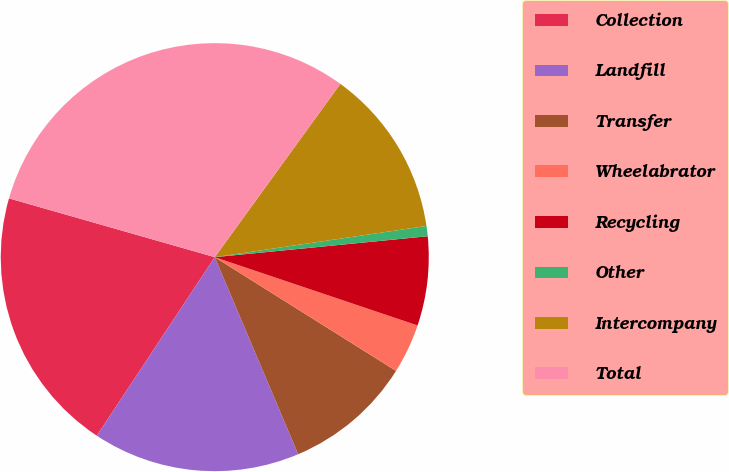<chart> <loc_0><loc_0><loc_500><loc_500><pie_chart><fcel>Collection<fcel>Landfill<fcel>Transfer<fcel>Wheelabrator<fcel>Recycling<fcel>Other<fcel>Intercompany<fcel>Total<nl><fcel>20.14%<fcel>15.67%<fcel>9.71%<fcel>3.75%<fcel>6.73%<fcel>0.77%<fcel>12.69%<fcel>30.56%<nl></chart> 